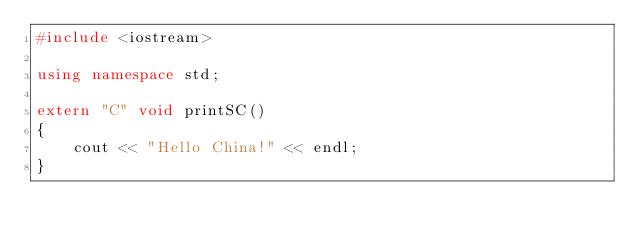<code> <loc_0><loc_0><loc_500><loc_500><_C++_>#include <iostream>

using namespace std;

extern "C" void printSC()
{
    cout << "Hello China!" << endl;
}
</code> 